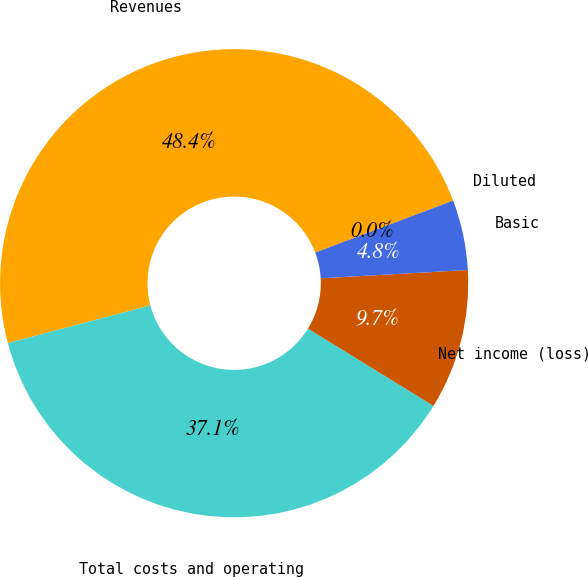Convert chart. <chart><loc_0><loc_0><loc_500><loc_500><pie_chart><fcel>Revenues<fcel>Total costs and operating<fcel>Net income (loss)<fcel>Basic<fcel>Diluted<nl><fcel>48.38%<fcel>37.1%<fcel>9.68%<fcel>4.84%<fcel>0.0%<nl></chart> 